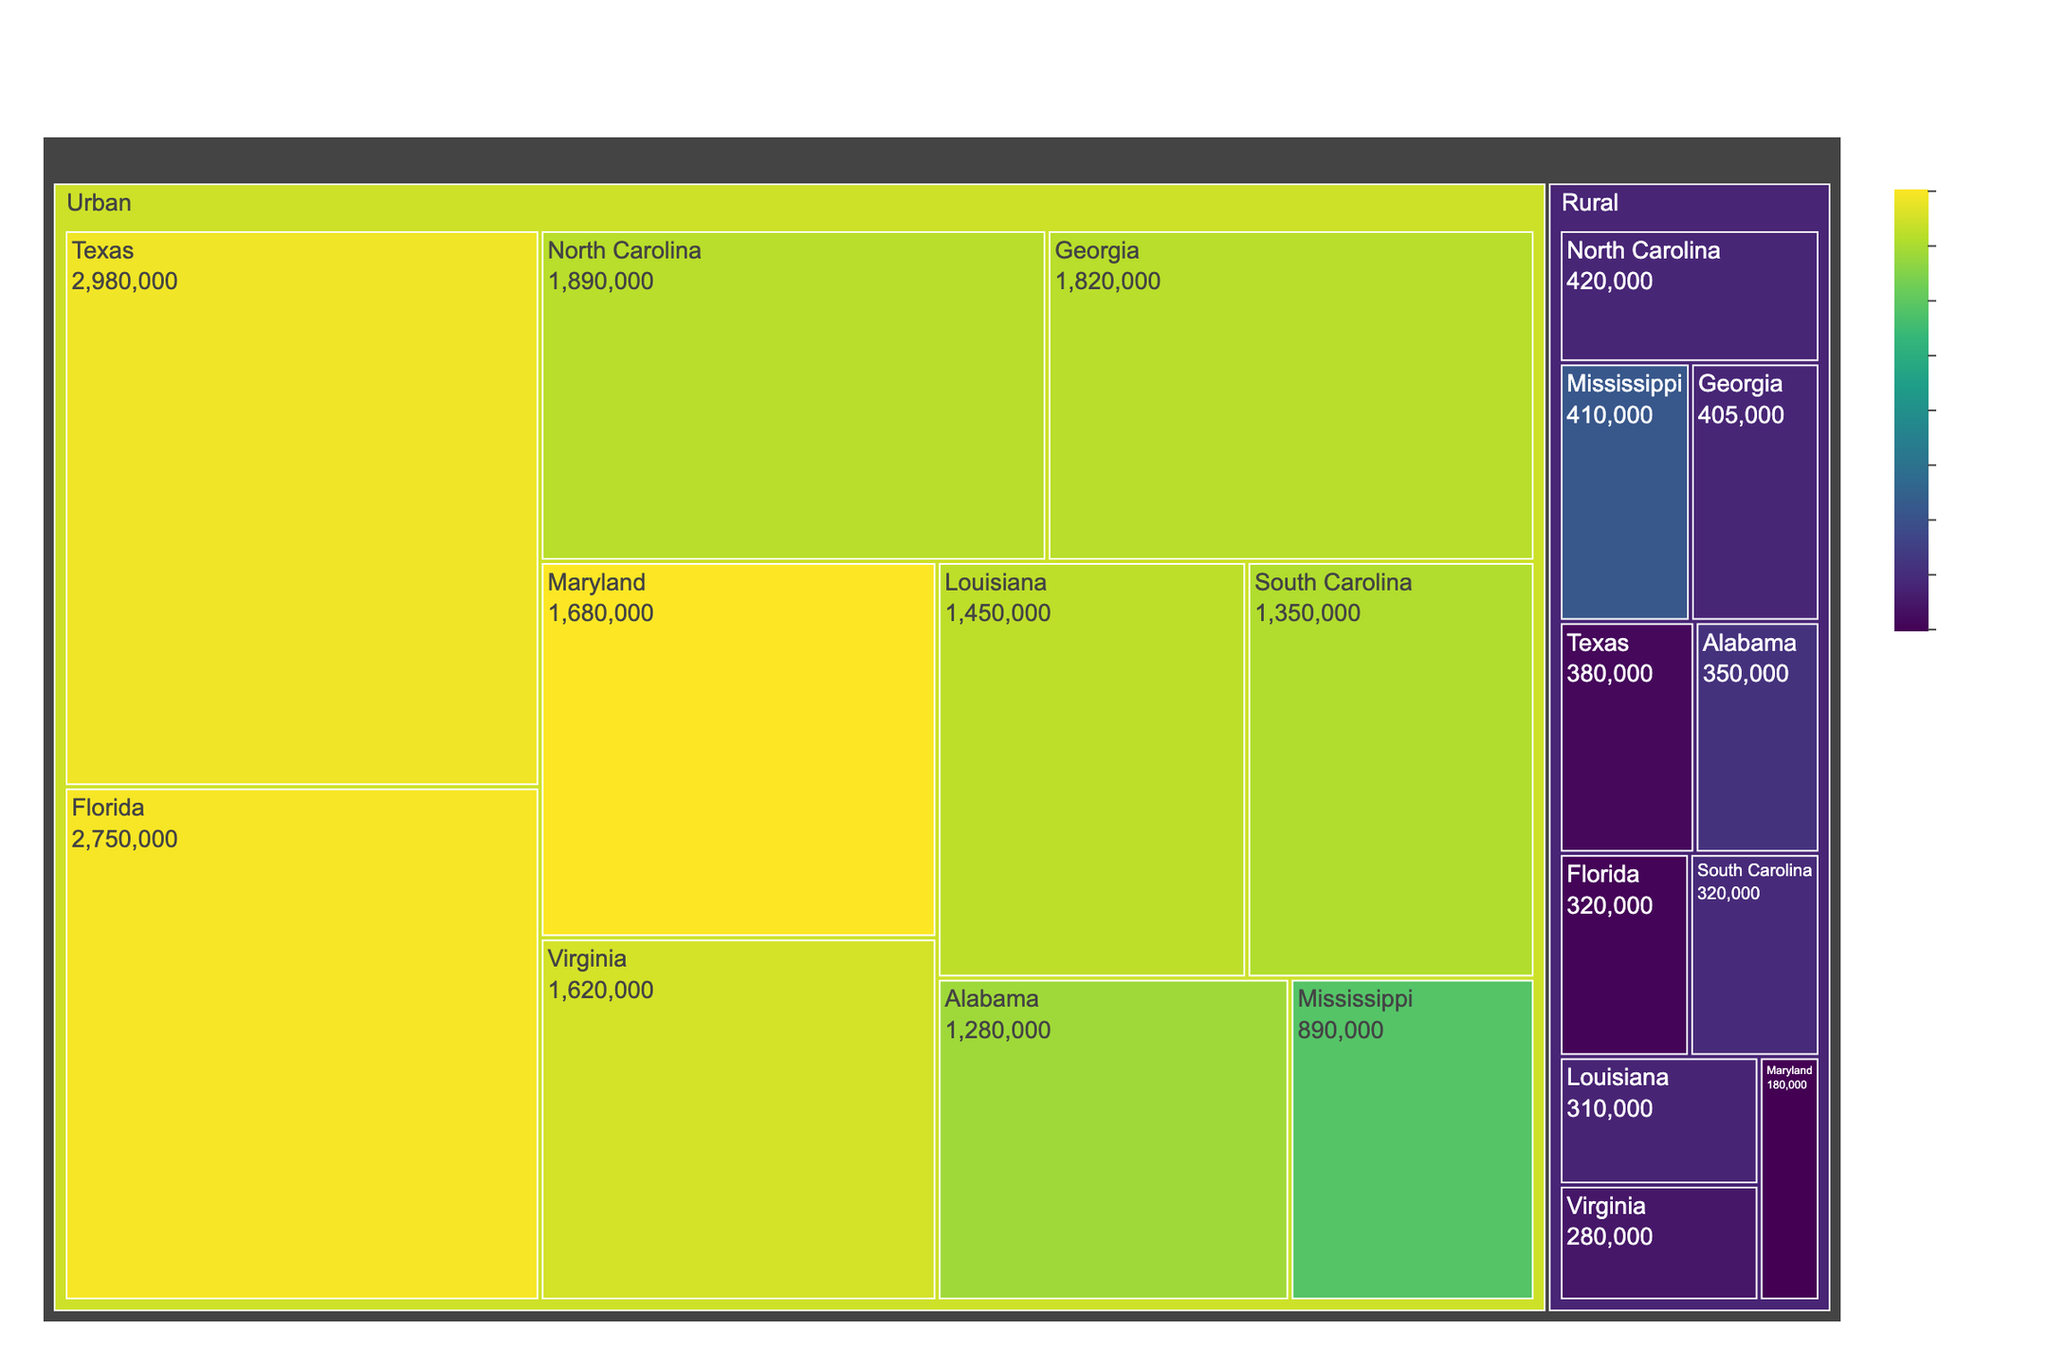Which state has the largest urban African American population? To find the state with the largest urban population, look at the data labeled "Urban" and compare the values. Texas has 2,980,000 as the highest figure.
Answer: Texas Which state has the smallest rural African American population? To identify the state with the smallest rural population, check the data labeled "Rural" and find the lowest value. Maryland has 180,000, which is the smallest.
Answer: Maryland What is the total African American population in Georgia? Add the urban and rural populations for Georgia: 1,820,000 (Urban) + 405,000 (Rural) = 2,225,000.
Answer: 2,225,000 Compare the urban populations of North Carolina and Florida. Which one is higher? Compare the numbers for the urban populations: North Carolina has 1,890,000 and Florida has 2,750,000. Florida's population is higher.
Answer: Florida What percentage of the total African American population in Mississippi is rural? To find the percentage, divide the rural population by the total population and multiply by 100. Rural population: 410,000, Total population: 1,300,000. (410,000 / 1,300,000) * 100 = 31.5%.
Answer: 31.5% Which state has a greater total African American population, Virginia or Maryland? Sum the urban and rural populations for both states: Virginia: 1,620,000 + 280,000 = 1,900,000, Maryland: 1,680,000 + 180,000 = 1,860,000. Virginia has a greater total population.
Answer: Virginia How does the rural population of Louisiana compare to that of Alabama? Compare the rural populations: Louisiana has 310,000 and Alabama has 350,000. Alabama's rural population is larger.
Answer: Alabama Which urban population is closer in size to the rural population of Texas? Compare the rural population of Texas (380,000) to the urban populations: Maryland's urban population of 1,680,000 is closest but not comparable in magnitude since it's significantly higher. The only closer value in terms of ratio is Alabama's rural population of 350,000.
Answer: Alabama What is the combined urban population of states starting with the letter "S"? Sum the urban populations of South Carolina: 1,350,000, and Mississippi: 890,000. South Carolina + Mississippi = 2,240,000.
Answer: 2,240,000 What color represents the highest percentage on the treemap? The color representing the highest percentage is the most intense color in the Viridis scale; look for the state with the darkest or brightest color, reflecting the highest percentage figure.
Answer: Darkest 